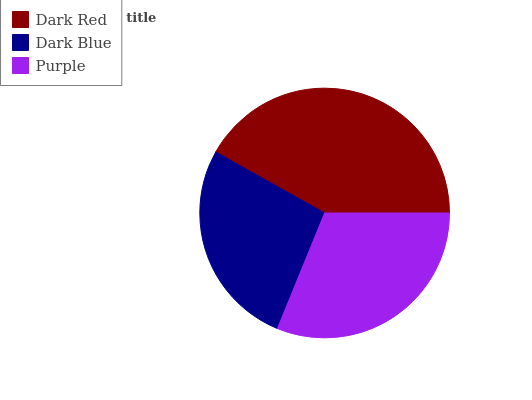Is Dark Blue the minimum?
Answer yes or no. Yes. Is Dark Red the maximum?
Answer yes or no. Yes. Is Purple the minimum?
Answer yes or no. No. Is Purple the maximum?
Answer yes or no. No. Is Purple greater than Dark Blue?
Answer yes or no. Yes. Is Dark Blue less than Purple?
Answer yes or no. Yes. Is Dark Blue greater than Purple?
Answer yes or no. No. Is Purple less than Dark Blue?
Answer yes or no. No. Is Purple the high median?
Answer yes or no. Yes. Is Purple the low median?
Answer yes or no. Yes. Is Dark Red the high median?
Answer yes or no. No. Is Dark Red the low median?
Answer yes or no. No. 